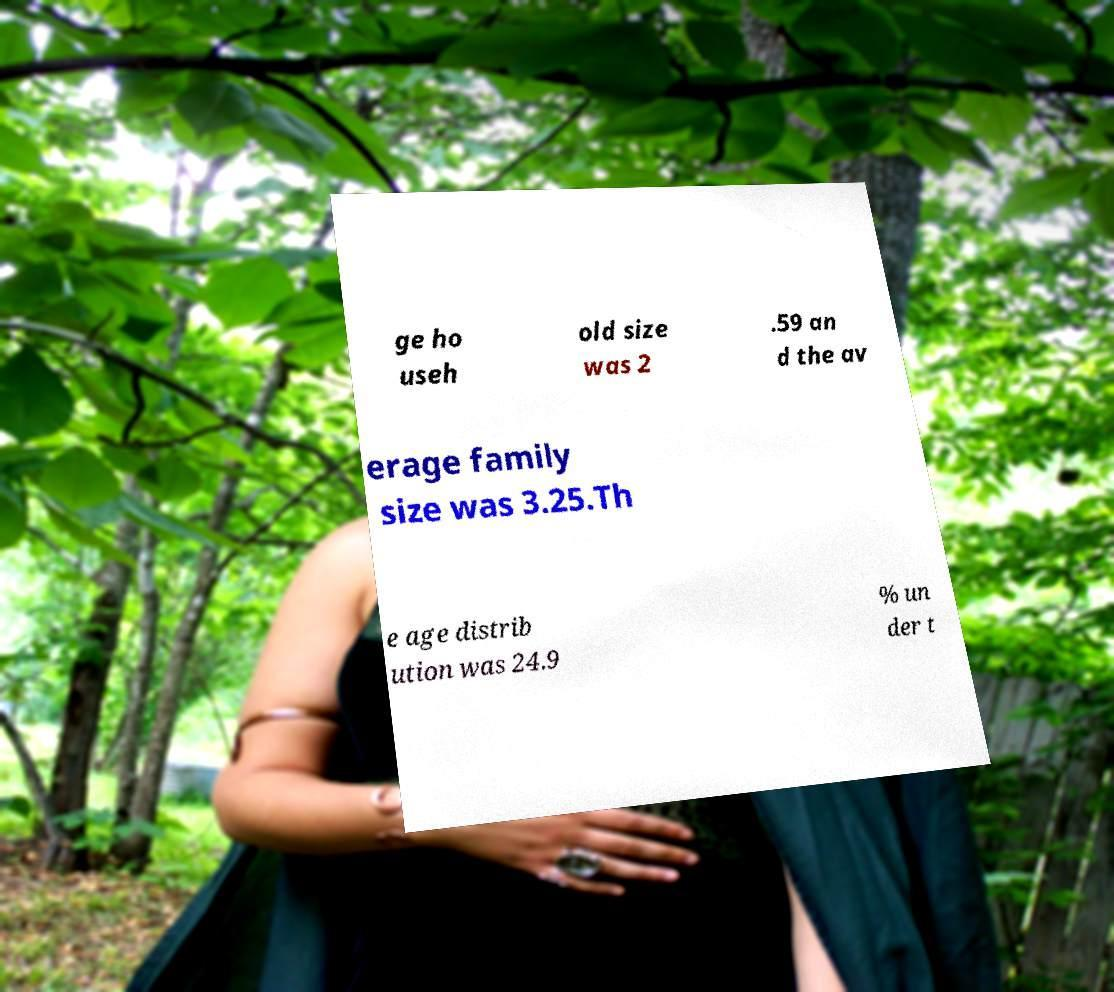For documentation purposes, I need the text within this image transcribed. Could you provide that? ge ho useh old size was 2 .59 an d the av erage family size was 3.25.Th e age distrib ution was 24.9 % un der t 